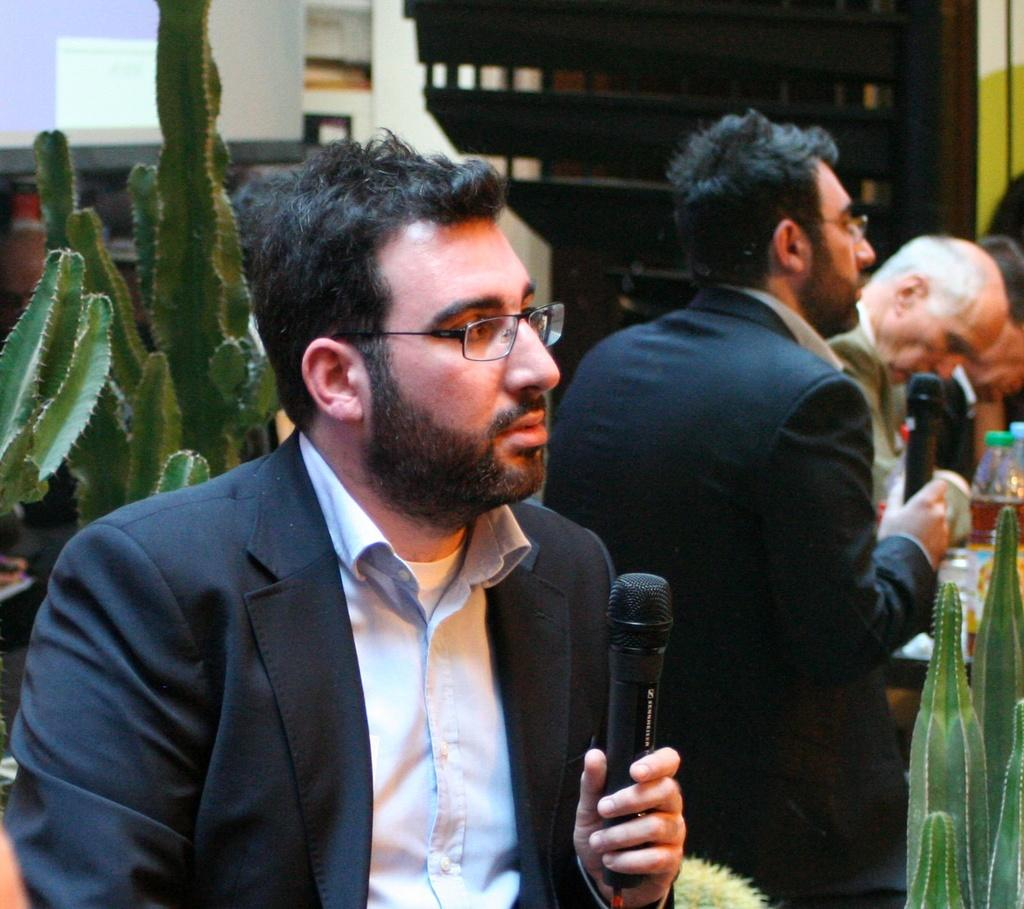What is the man in the image holding? The man is holding a microphone in the image. Can you describe the setting in which the man is holding the microphone? There are other people visible in the background, suggesting that the man may be in a public or performance setting. What type of plant can be seen in the image? There is a plant in the image. What type of furniture is present in the image? There is a wooden cupboard in the image. What type of nut is being cracked by the man holding the microphone? There is no nut present in the image, nor is the man holding a nut or cracking one. 